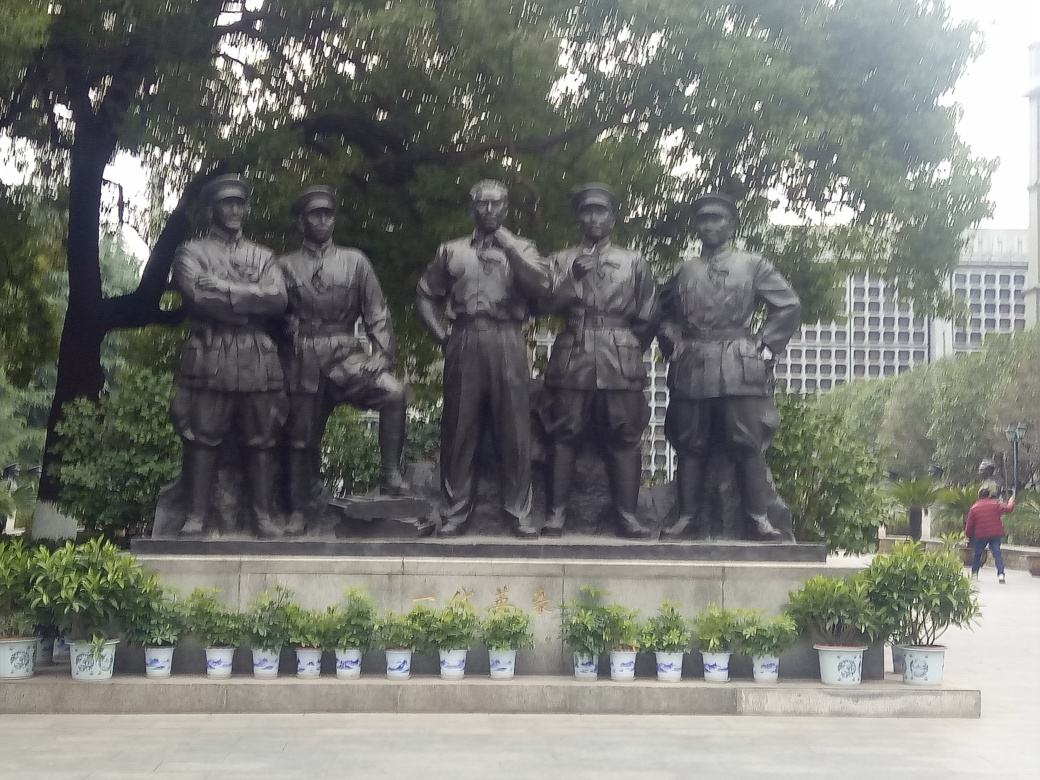Is the image overexposed? The image is not severely overexposed, but it has areas where the lighting could be more balanced. The sky in the background, for example, lacks detail which could be due to excessive brightness in that area, a common trait of mild overexposure. 